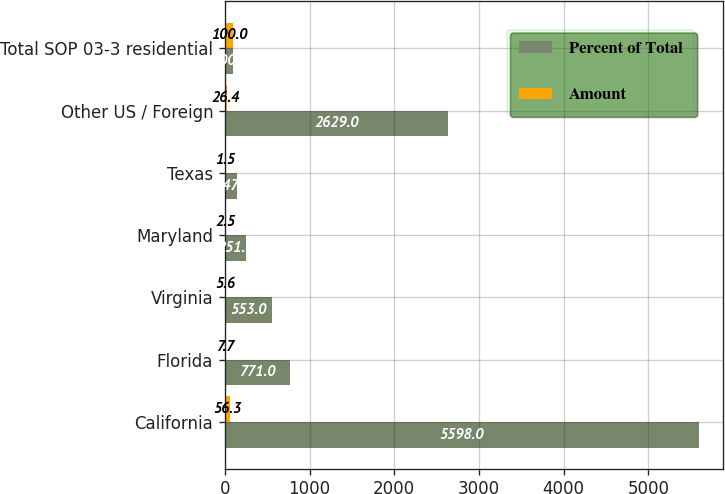<chart> <loc_0><loc_0><loc_500><loc_500><stacked_bar_chart><ecel><fcel>California<fcel>Florida<fcel>Virginia<fcel>Maryland<fcel>Texas<fcel>Other US / Foreign<fcel>Total SOP 03-3 residential<nl><fcel>Percent of Total<fcel>5598<fcel>771<fcel>553<fcel>251<fcel>147<fcel>2629<fcel>100<nl><fcel>Amount<fcel>56.3<fcel>7.7<fcel>5.6<fcel>2.5<fcel>1.5<fcel>26.4<fcel>100<nl></chart> 